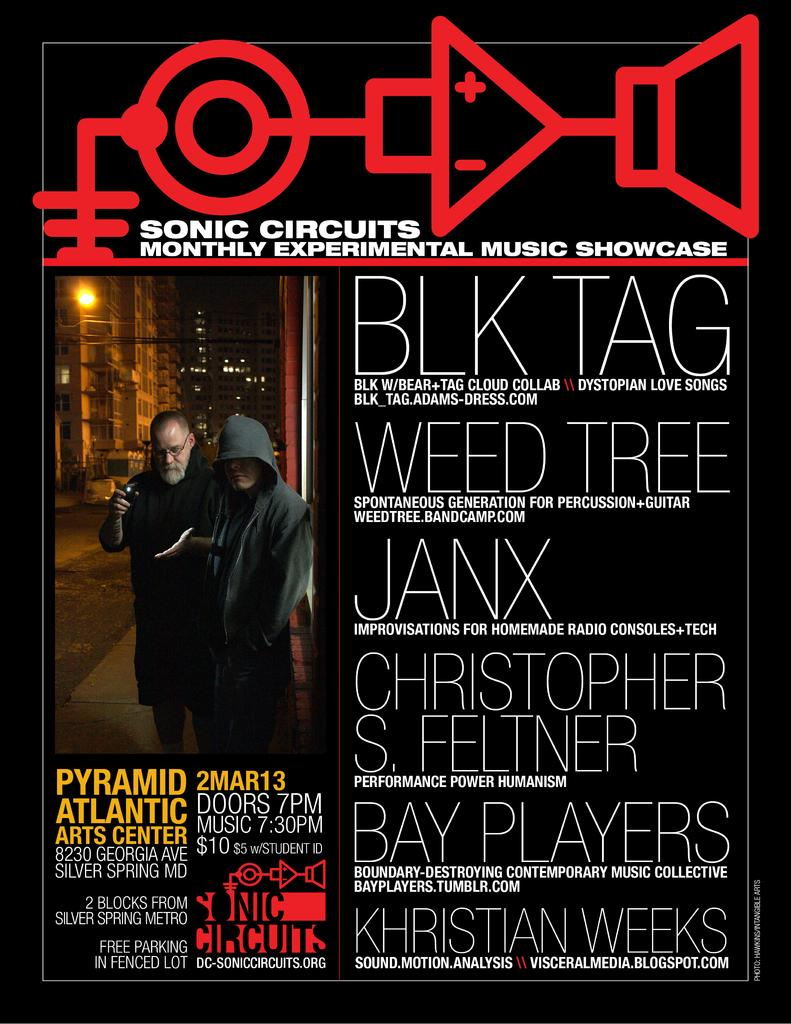What type of visual is the image? The image is a poster. What can be seen in the poster with regards to people? There are two men standing on a footpath in the poster. What type of structure is visible in the poster? There is a building visible in the poster. What else can be seen in the poster besides the people and building? There are lights and some text in the poster. What type of fruit is being peeled by one of the men in the poster? There is no fruit, such as a banana, visible in the poster. What type of beverage is being consumed by one of the men in the poster? There is no beverage, such as soda, visible in the poster. 